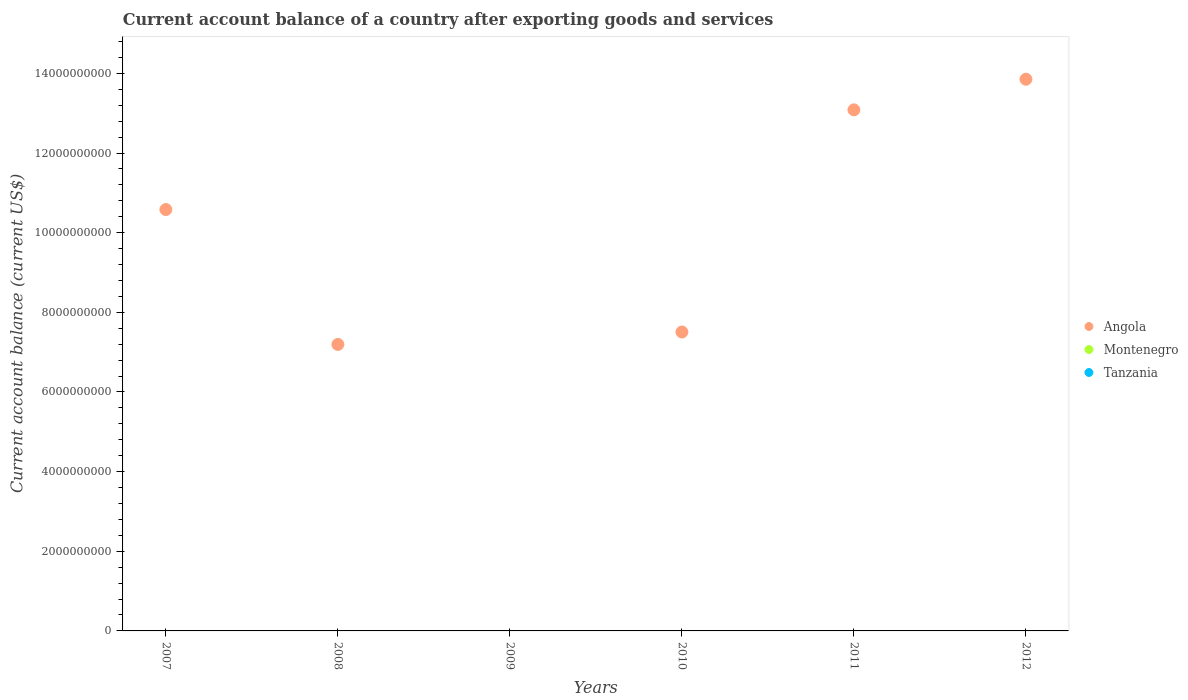What is the account balance in Angola in 2008?
Offer a very short reply. 7.19e+09. Across all years, what is the maximum account balance in Angola?
Your answer should be very brief. 1.39e+1. Across all years, what is the minimum account balance in Tanzania?
Provide a succinct answer. 0. What is the difference between the account balance in Angola in 2007 and that in 2012?
Give a very brief answer. -3.27e+09. What is the difference between the account balance in Montenegro in 2010 and the account balance in Angola in 2007?
Your answer should be very brief. -1.06e+1. What is the average account balance in Tanzania per year?
Your response must be concise. 0. In how many years, is the account balance in Angola greater than 4800000000 US$?
Your response must be concise. 5. What is the difference between the highest and the second highest account balance in Angola?
Ensure brevity in your answer.  7.69e+08. What is the difference between the highest and the lowest account balance in Angola?
Offer a terse response. 1.39e+1. Is the sum of the account balance in Angola in 2011 and 2012 greater than the maximum account balance in Montenegro across all years?
Your response must be concise. Yes. Is the account balance in Angola strictly greater than the account balance in Montenegro over the years?
Offer a terse response. No. Are the values on the major ticks of Y-axis written in scientific E-notation?
Keep it short and to the point. No. Does the graph contain any zero values?
Your response must be concise. Yes. Does the graph contain grids?
Your answer should be compact. No. Where does the legend appear in the graph?
Keep it short and to the point. Center right. How many legend labels are there?
Give a very brief answer. 3. What is the title of the graph?
Ensure brevity in your answer.  Current account balance of a country after exporting goods and services. What is the label or title of the X-axis?
Provide a succinct answer. Years. What is the label or title of the Y-axis?
Offer a very short reply. Current account balance (current US$). What is the Current account balance (current US$) of Angola in 2007?
Give a very brief answer. 1.06e+1. What is the Current account balance (current US$) in Montenegro in 2007?
Offer a terse response. 0. What is the Current account balance (current US$) in Tanzania in 2007?
Offer a terse response. 0. What is the Current account balance (current US$) of Angola in 2008?
Offer a very short reply. 7.19e+09. What is the Current account balance (current US$) of Montenegro in 2009?
Keep it short and to the point. 0. What is the Current account balance (current US$) in Angola in 2010?
Offer a terse response. 7.51e+09. What is the Current account balance (current US$) in Angola in 2011?
Your answer should be very brief. 1.31e+1. What is the Current account balance (current US$) of Montenegro in 2011?
Your answer should be very brief. 0. What is the Current account balance (current US$) in Tanzania in 2011?
Your answer should be very brief. 0. What is the Current account balance (current US$) of Angola in 2012?
Ensure brevity in your answer.  1.39e+1. What is the Current account balance (current US$) of Montenegro in 2012?
Keep it short and to the point. 0. Across all years, what is the maximum Current account balance (current US$) of Angola?
Offer a very short reply. 1.39e+1. What is the total Current account balance (current US$) of Angola in the graph?
Provide a short and direct response. 5.22e+1. What is the total Current account balance (current US$) in Montenegro in the graph?
Make the answer very short. 0. What is the total Current account balance (current US$) of Tanzania in the graph?
Keep it short and to the point. 0. What is the difference between the Current account balance (current US$) in Angola in 2007 and that in 2008?
Offer a terse response. 3.39e+09. What is the difference between the Current account balance (current US$) in Angola in 2007 and that in 2010?
Offer a very short reply. 3.08e+09. What is the difference between the Current account balance (current US$) in Angola in 2007 and that in 2011?
Offer a terse response. -2.50e+09. What is the difference between the Current account balance (current US$) in Angola in 2007 and that in 2012?
Offer a very short reply. -3.27e+09. What is the difference between the Current account balance (current US$) of Angola in 2008 and that in 2010?
Your response must be concise. -3.12e+08. What is the difference between the Current account balance (current US$) in Angola in 2008 and that in 2011?
Make the answer very short. -5.89e+09. What is the difference between the Current account balance (current US$) of Angola in 2008 and that in 2012?
Make the answer very short. -6.66e+09. What is the difference between the Current account balance (current US$) of Angola in 2010 and that in 2011?
Provide a succinct answer. -5.58e+09. What is the difference between the Current account balance (current US$) in Angola in 2010 and that in 2012?
Offer a very short reply. -6.35e+09. What is the difference between the Current account balance (current US$) of Angola in 2011 and that in 2012?
Provide a short and direct response. -7.69e+08. What is the average Current account balance (current US$) in Angola per year?
Ensure brevity in your answer.  8.70e+09. What is the average Current account balance (current US$) of Tanzania per year?
Make the answer very short. 0. What is the ratio of the Current account balance (current US$) in Angola in 2007 to that in 2008?
Give a very brief answer. 1.47. What is the ratio of the Current account balance (current US$) of Angola in 2007 to that in 2010?
Make the answer very short. 1.41. What is the ratio of the Current account balance (current US$) of Angola in 2007 to that in 2011?
Your answer should be very brief. 0.81. What is the ratio of the Current account balance (current US$) in Angola in 2007 to that in 2012?
Offer a very short reply. 0.76. What is the ratio of the Current account balance (current US$) in Angola in 2008 to that in 2010?
Your response must be concise. 0.96. What is the ratio of the Current account balance (current US$) of Angola in 2008 to that in 2011?
Make the answer very short. 0.55. What is the ratio of the Current account balance (current US$) in Angola in 2008 to that in 2012?
Your answer should be very brief. 0.52. What is the ratio of the Current account balance (current US$) of Angola in 2010 to that in 2011?
Your answer should be compact. 0.57. What is the ratio of the Current account balance (current US$) in Angola in 2010 to that in 2012?
Your answer should be very brief. 0.54. What is the ratio of the Current account balance (current US$) in Angola in 2011 to that in 2012?
Make the answer very short. 0.94. What is the difference between the highest and the second highest Current account balance (current US$) of Angola?
Give a very brief answer. 7.69e+08. What is the difference between the highest and the lowest Current account balance (current US$) of Angola?
Keep it short and to the point. 1.39e+1. 